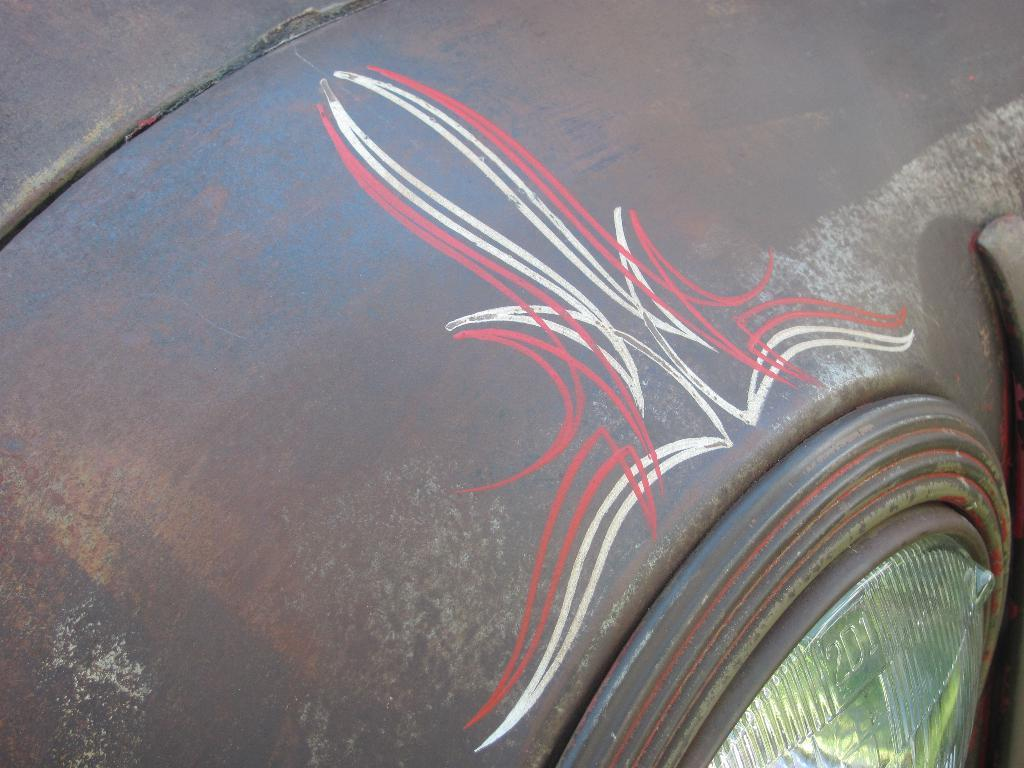What is featured on the vehicle in the image? There is a design on a vehicle in the image. Can you describe any specific features of the vehicle? Yes, there is a light on the vehicle in the image. Where is the throne located in the image? There is no throne present in the image. What type of mitten can be seen on the driver's hand in the image? There is no driver or mitten present in the image. 